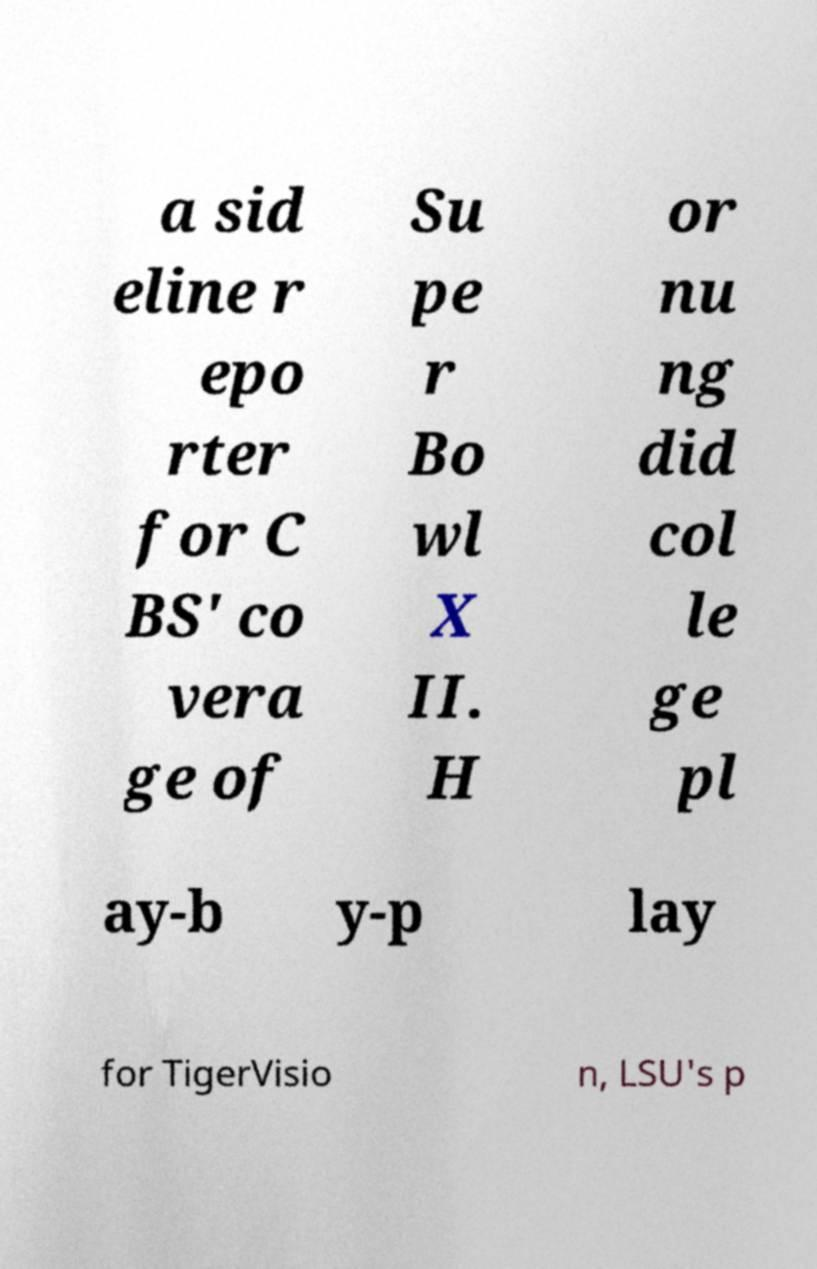Can you read and provide the text displayed in the image?This photo seems to have some interesting text. Can you extract and type it out for me? a sid eline r epo rter for C BS' co vera ge of Su pe r Bo wl X II. H or nu ng did col le ge pl ay-b y-p lay for TigerVisio n, LSU's p 